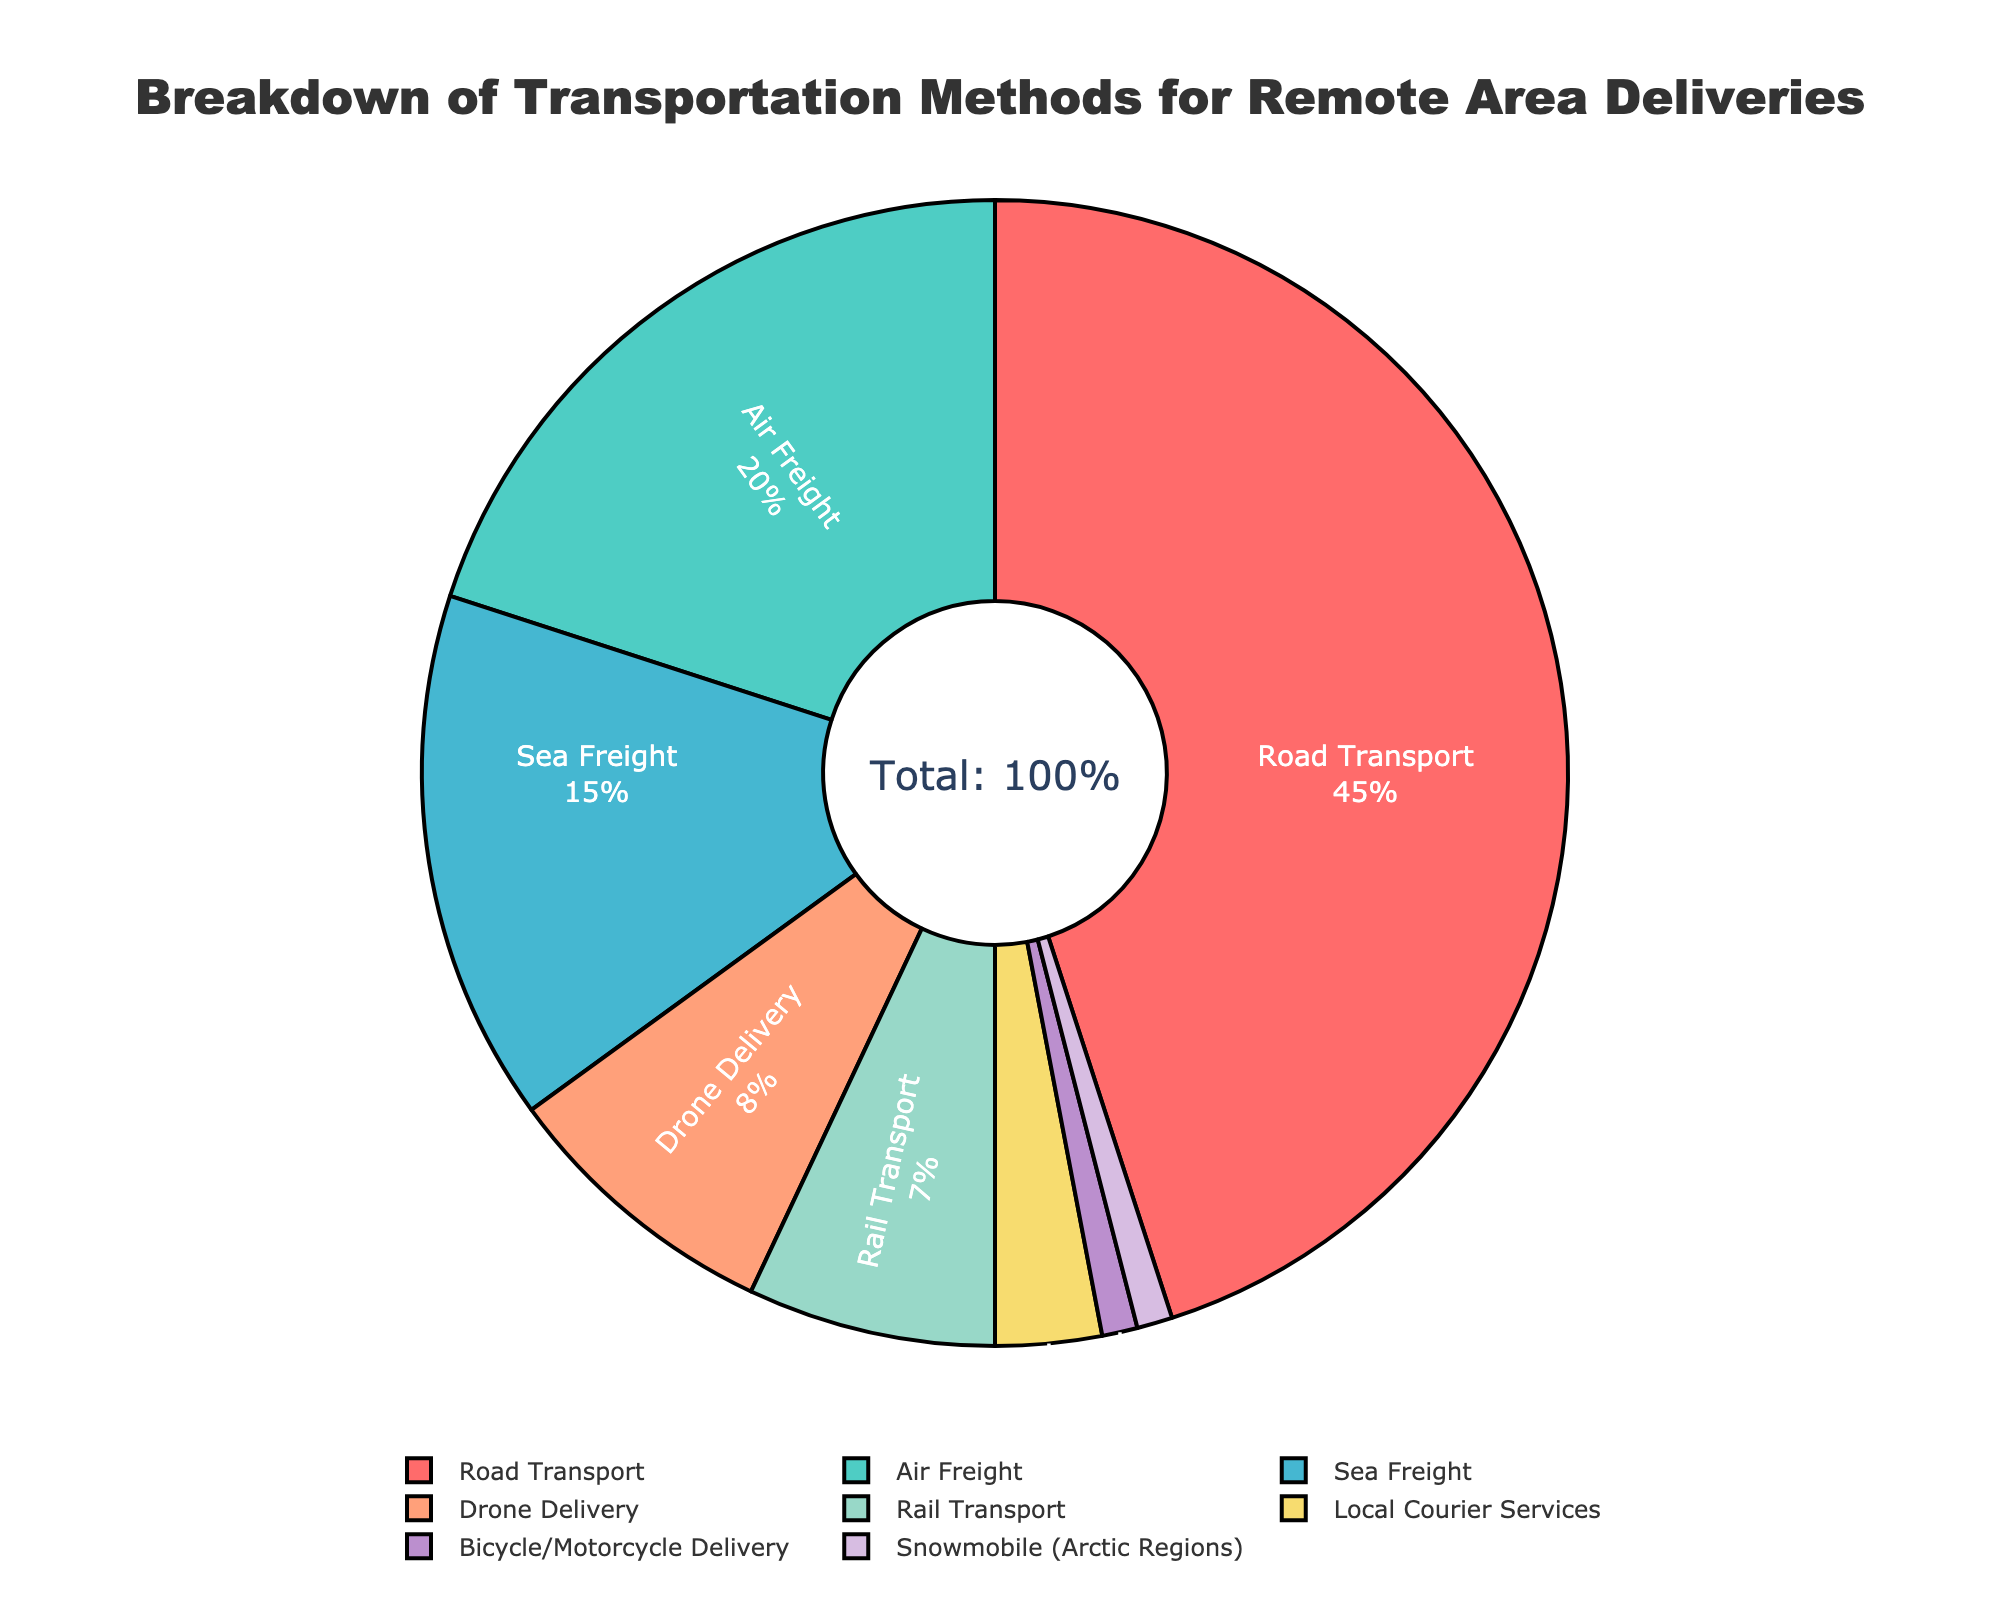What percentage of deliveries is done using Road Transport? Road Transport occupies 45% of the transportation methods for remote area deliveries as seen in the pie chart by looking at the labeled segment.
Answer: 45% What are the combined percentages for Road Transport and Air Freight? Add the percentage of Road Transport (45%) to that of Air Freight (20%). 45% + 20% = 65%.
Answer: 65% Which transportation method has the smallest share of deliveries, and what is this share? Bicycle/Motorcycle Delivery and Snowmobile (Arctic Regions) both have the smallest shares, each making up 1% of the deliveries.
Answer: Bicycle/Motorcycle Delivery and Snowmobile (Arctic Regions), 1% Is the percentage for Drone Delivery greater than that for Rail Transport? Compare the two labeled segments: Drone Delivery has 8%, and Rail Transport has 7%. 8% is greater than 7%.
Answer: Yes What are the visual differences between the segments for Road Transport and Snowmobile (Arctic Regions)? The Road Transport segment is much larger and colored red, occupying 45%, whereas the Snowmobile (Arctic Regions) segment is much smaller and colored purple, occupying 1%.
Answer: Road Transport is larger and red, Snowmobile (Arctic Regions) is smaller and purple By how much does the percentage of Road Transport exceed the combined percentage of Local Courier Services and Bicycle/Motorcycle Delivery? Sum Local Courier Services (3%) and Bicycle/Motorcycle Delivery (1%) to get 4%. The difference between Road Transport (45%) and this combined percentage is 45% - 4% = 41%.
Answer: 41% Rank the transportation methods from highest to lowest percentage. The highest is Road Transport (45%), followed by Air Freight (20%), Sea Freight (15%), Drone Delivery (8%), Rail Transport (7%), Local Courier Services (3%), Bicycle/Motorcycle Delivery (1%), and Snowmobile (Arctic Regions) (1%).
Answer: Road Transport > Air Freight > Sea Freight > Drone Delivery > Rail Transport > Local Courier Services > Bicycle/Motorcycle Delivery = Snowmobile (Arctic Regions) Is the percentage for Sea Freight closer to Air Freight or to Drone Delivery? Calculate the differences: Sea Freight (15%) and Air Freight (20%) difference is 5%, and with Drone Delivery (8%) is 7%. 5% is smaller than 7%, so Sea Freight is closer to Air Freight.
Answer: Air Freight What's the combined percentage of all transportation methods under 5%? Sum the percentages under 5%: Local Courier Services (3%) + Bicycle/Motorcycle Delivery (1%) + Snowmobile (Arctic Regions) (1%) = 5%.
Answer: 5% What percentage do alternative delivery methods (like Drones and Bicycles/Motorcycles) collectively account for? Add percentages for Drone Delivery (8%) and Bicycle/Motorcycle Delivery (1%). 8% + 1% = 9%.
Answer: 9% 